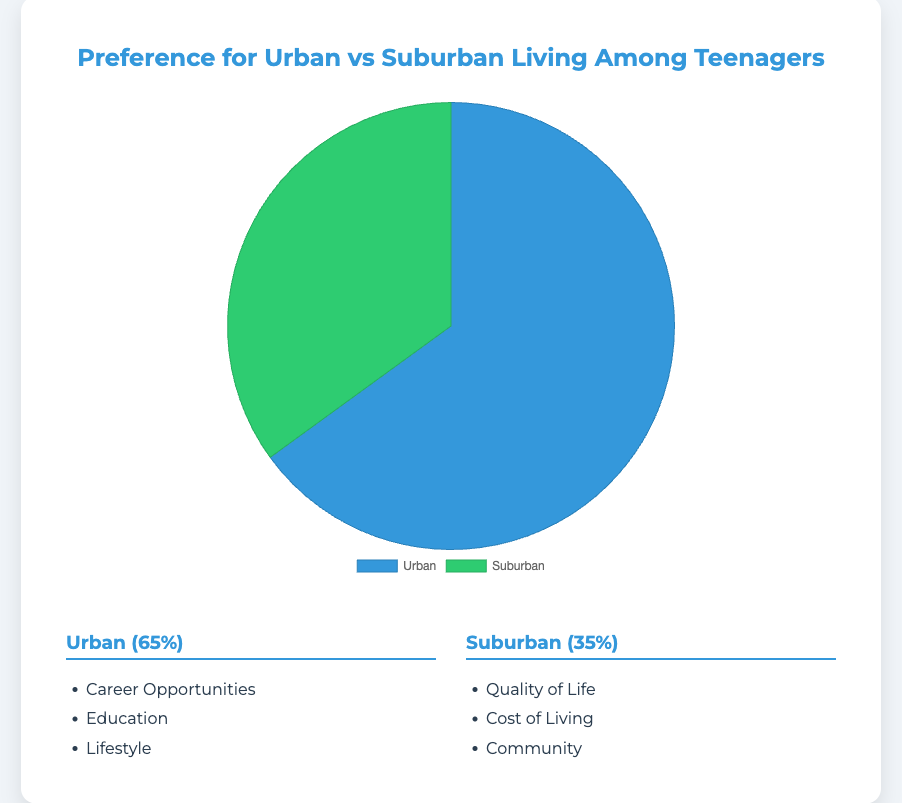What are the two main categories of living preferences among teenagers? The chart shows two main categories of living preferences: Urban and Suburban.
Answer: Urban and Suburban What percentage of teenagers prefer urban living? The chart shows that 65% of teenagers prefer urban living.
Answer: 65% Which preference is more popular among teenagers, urban or suburban living? The chart shows the data points as Urban with 65% and Suburban with 35%, indicating that Urban is more popular.
Answer: Urban By what percentage does the preference for urban living exceed that of suburban living? Urban preference is 65%, and Suburban preference is 35%. The difference is 65% - 35% = 30%.
Answer: 30% Which reason is listed under both Urban and Suburban living? By examining the reasons for both preferences, there is no overlapping reason between Urban and Suburban living.
Answer: None What is one example of a reason for preferring urban living due to career opportunities? One example mentioned is "Access to diverse job markets."
Answer: Access to diverse job markets What is one of the reasons for teenagers preferring suburban living for quality of life? One reason listed is "Recreational spaces."
Answer: Recreational spaces What color represents the suburban living preference in the pie chart? The Suburban living preference is represented by green in the pie chart as stated in the code.
Answer: Green If the sample size is 100 teenagers, how many prefer suburban living? Given 35% prefer suburban living, so 35% of 100 equals 35.
Answer: 35 Compare the lifestyle reasons provided for each preference. Which one seems more focused on community? The suburban preference includes "closer-knit communities" and "better environment for raising a family," which are more community-focused than the urban lifestyle reasons like "vibrant cultural scene" and "better public transportation."
Answer: Suburban What is the combined percentage of teenagers who prefer urban and suburban living? The chart accounts for all living preferences, so the combined percentage is 65% + 35% = 100%.
Answer: 100% 